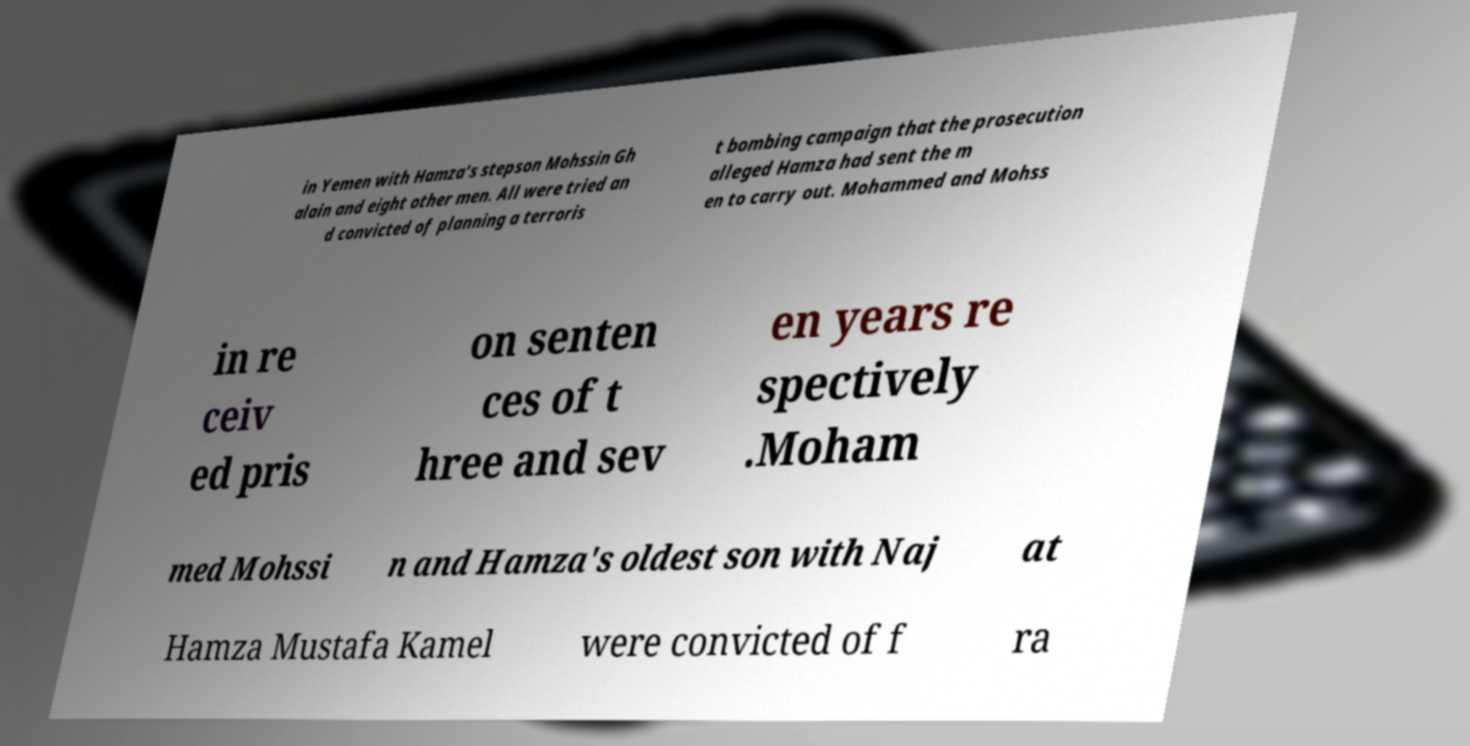Could you assist in decoding the text presented in this image and type it out clearly? in Yemen with Hamza's stepson Mohssin Gh alain and eight other men. All were tried an d convicted of planning a terroris t bombing campaign that the prosecution alleged Hamza had sent the m en to carry out. Mohammed and Mohss in re ceiv ed pris on senten ces of t hree and sev en years re spectively .Moham med Mohssi n and Hamza's oldest son with Naj at Hamza Mustafa Kamel were convicted of f ra 